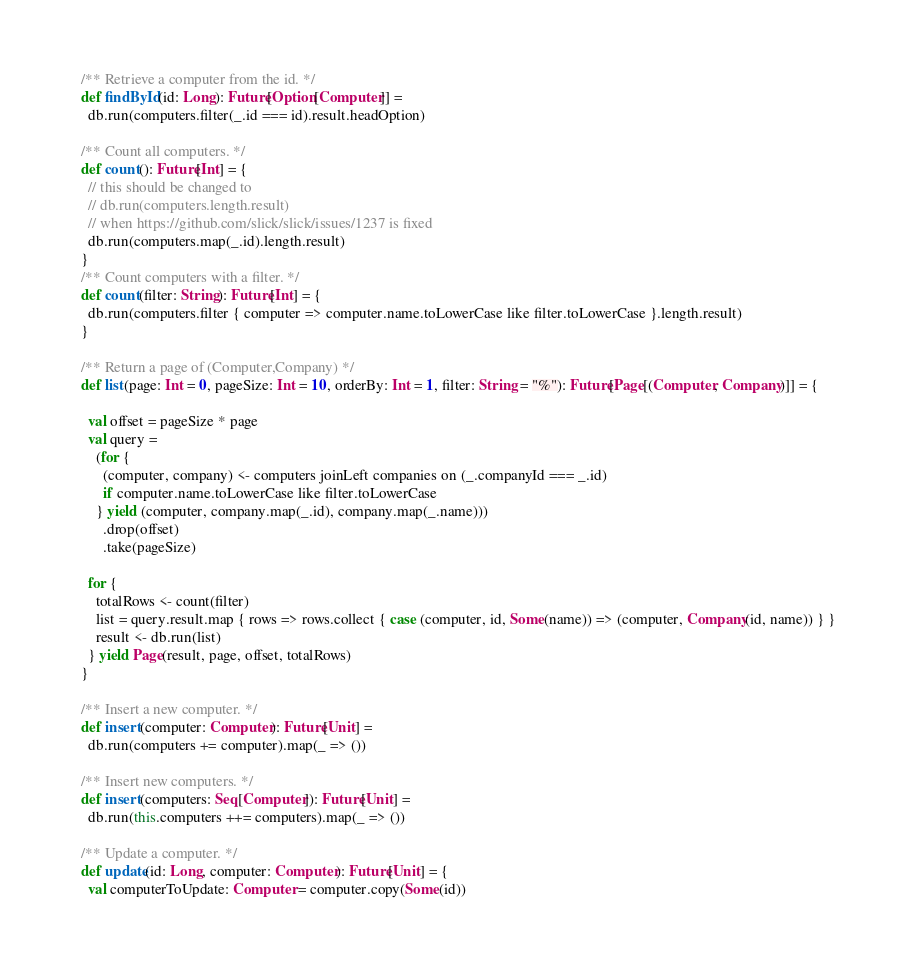Convert code to text. <code><loc_0><loc_0><loc_500><loc_500><_Scala_>
  /** Retrieve a computer from the id. */
  def findById(id: Long): Future[Option[Computer]] =
    db.run(computers.filter(_.id === id).result.headOption)

  /** Count all computers. */
  def count(): Future[Int] = {
    // this should be changed to
    // db.run(computers.length.result)
    // when https://github.com/slick/slick/issues/1237 is fixed
    db.run(computers.map(_.id).length.result)
  }
  /** Count computers with a filter. */
  def count(filter: String): Future[Int] = {
    db.run(computers.filter { computer => computer.name.toLowerCase like filter.toLowerCase }.length.result)
  }

  /** Return a page of (Computer,Company) */
  def list(page: Int = 0, pageSize: Int = 10, orderBy: Int = 1, filter: String = "%"): Future[Page[(Computer, Company)]] = {

    val offset = pageSize * page
    val query =
      (for {
        (computer, company) <- computers joinLeft companies on (_.companyId === _.id)
        if computer.name.toLowerCase like filter.toLowerCase
      } yield (computer, company.map(_.id), company.map(_.name)))
        .drop(offset)
        .take(pageSize)

    for {
      totalRows <- count(filter)
      list = query.result.map { rows => rows.collect { case (computer, id, Some(name)) => (computer, Company(id, name)) } }
      result <- db.run(list)
    } yield Page(result, page, offset, totalRows)
  }

  /** Insert a new computer. */
  def insert(computer: Computer): Future[Unit] =
    db.run(computers += computer).map(_ => ())

  /** Insert new computers. */
  def insert(computers: Seq[Computer]): Future[Unit] =
    db.run(this.computers ++= computers).map(_ => ())

  /** Update a computer. */
  def update(id: Long, computer: Computer): Future[Unit] = {
    val computerToUpdate: Computer = computer.copy(Some(id))</code> 